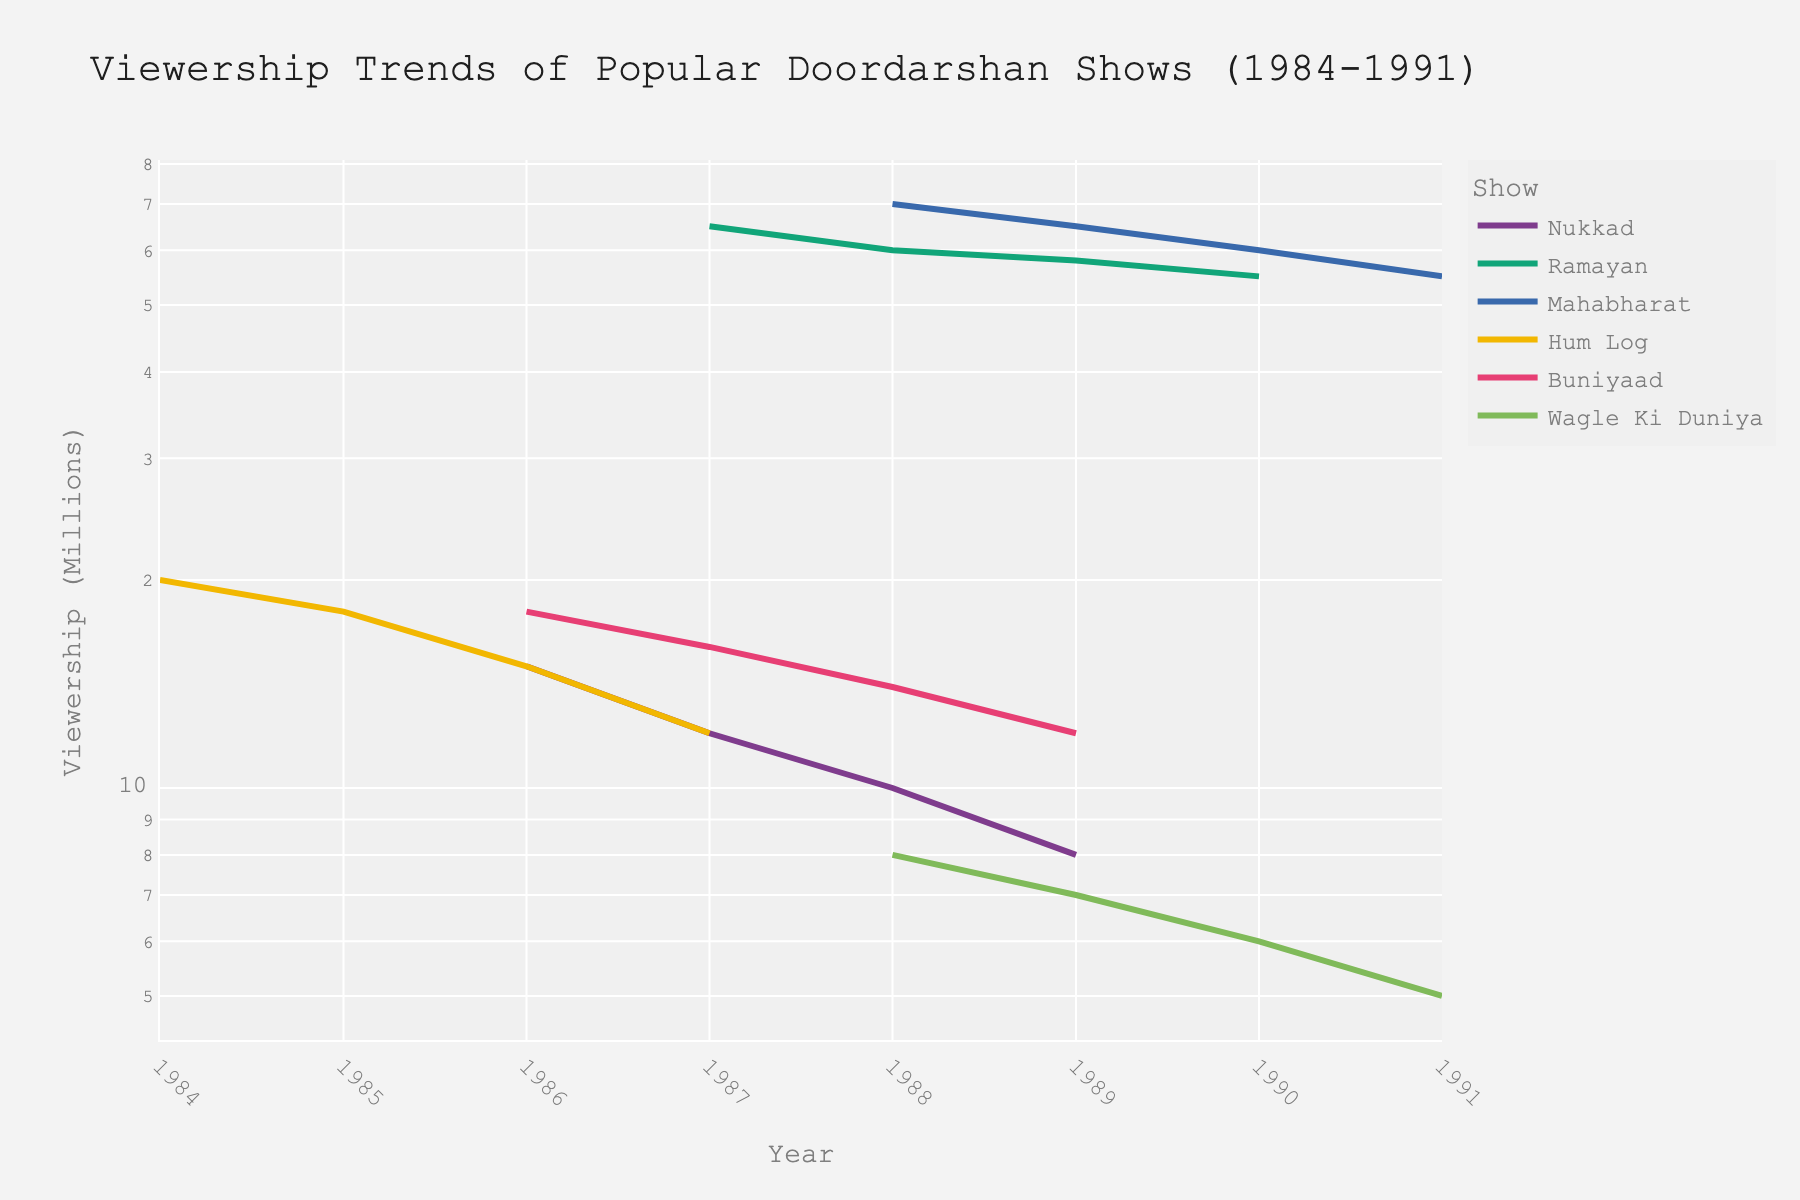What's the title of the plot? The title of the plot is written at the top, indicating what the visual represents.
Answer: Viewership Trends of Popular Doordarshan Shows (1984-1991) How many shows are represented in the figure? The number of distinct colors in the plot corresponds to the number of different shows represented.
Answer: 6 Which show had the highest viewership at any given year? Look for the show with the line plotted at the highest point on the y-axis.
Answer: Mahabharat How did the viewership of "Ramayan" change from 1987 to 1990? Track the line for "Ramayan" from 1987 to 1990 and note the y-axis values (in millions).
Answer: Decreased from 65 million to 55 million Which show had a viewership drop to 5 million in 1991? Look for the line that reaches the 5 million mark in the year 1991.
Answer: Wagle Ki Duniya Compare the viewership trends of "Nukkad" and "Buniyaad" from 1986 to 1989. Which show had a steeper decline? Calculate the rate of decline for both shows over the specified years by comparing viewership changes.
Answer: Nukkad What was the average viewership of “Hum Log” over the years it was listed? Compute the average by adding the viewership values of "Hum Log" and dividing by the total number of years it was aired.
Answer: 16.25 million Which show had the most consistent viewership trend over the years, with minimal fluctuations? Identify the show with the least variation in its line plot over the years.
Answer: Buniyaad Did "Mahabharat" and "Ramayan" ever have the same viewership in any given year? Check the data points for both "Mahabharat" and "Ramayan" for any overlap in viewership values across the years.
Answer: No Based on the plot, which show would you say was the most popular overall? The show with the highest overall position and widely seen consistent high viewership.
Answer: Mahabharat 